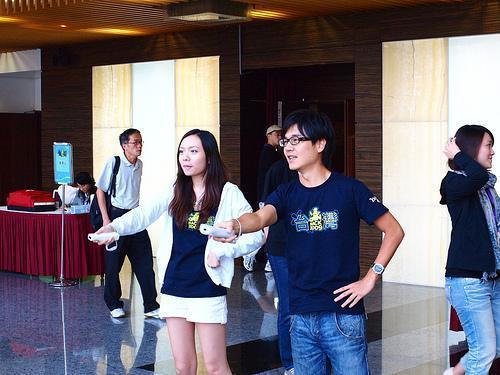How many people are playing a game?
Give a very brief answer. 2. How many people are pictured?
Give a very brief answer. 5. 